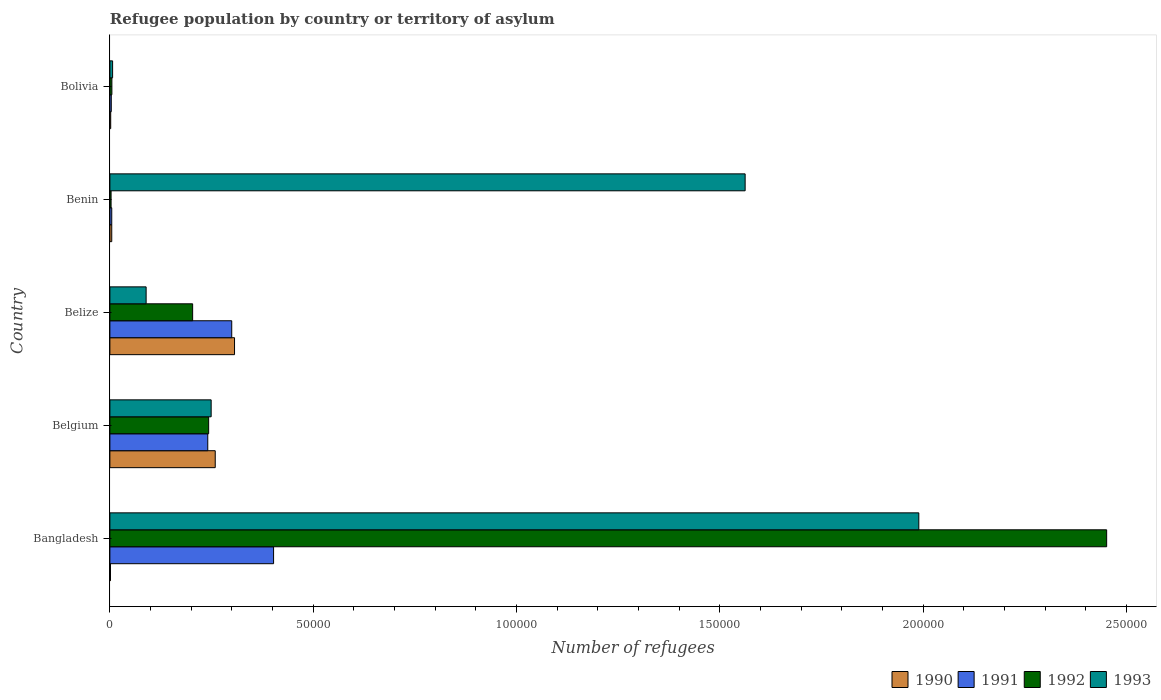How many different coloured bars are there?
Offer a very short reply. 4. How many groups of bars are there?
Your answer should be compact. 5. Are the number of bars per tick equal to the number of legend labels?
Your answer should be very brief. Yes. How many bars are there on the 3rd tick from the top?
Make the answer very short. 4. What is the label of the 5th group of bars from the top?
Your answer should be very brief. Bangladesh. What is the number of refugees in 1992 in Belize?
Offer a very short reply. 2.04e+04. Across all countries, what is the maximum number of refugees in 1991?
Provide a succinct answer. 4.03e+04. Across all countries, what is the minimum number of refugees in 1992?
Your response must be concise. 293. What is the total number of refugees in 1991 in the graph?
Your answer should be compact. 9.51e+04. What is the difference between the number of refugees in 1990 in Belgium and that in Bolivia?
Keep it short and to the point. 2.57e+04. What is the difference between the number of refugees in 1993 in Bolivia and the number of refugees in 1990 in Benin?
Offer a terse response. 213. What is the average number of refugees in 1991 per country?
Provide a short and direct response. 1.90e+04. What is the difference between the number of refugees in 1990 and number of refugees in 1991 in Bangladesh?
Your answer should be compact. -4.01e+04. In how many countries, is the number of refugees in 1991 greater than 90000 ?
Offer a very short reply. 0. What is the ratio of the number of refugees in 1993 in Belize to that in Bolivia?
Ensure brevity in your answer.  13.32. Is the difference between the number of refugees in 1990 in Belgium and Bolivia greater than the difference between the number of refugees in 1991 in Belgium and Bolivia?
Your answer should be compact. Yes. What is the difference between the highest and the second highest number of refugees in 1993?
Offer a very short reply. 4.27e+04. What is the difference between the highest and the lowest number of refugees in 1993?
Your answer should be compact. 1.98e+05. In how many countries, is the number of refugees in 1991 greater than the average number of refugees in 1991 taken over all countries?
Your answer should be compact. 3. What does the 3rd bar from the top in Bangladesh represents?
Your answer should be compact. 1991. What does the 4th bar from the bottom in Belgium represents?
Make the answer very short. 1993. Is it the case that in every country, the sum of the number of refugees in 1990 and number of refugees in 1992 is greater than the number of refugees in 1993?
Your answer should be compact. No. How many bars are there?
Offer a terse response. 20. Are all the bars in the graph horizontal?
Give a very brief answer. Yes. Does the graph contain grids?
Ensure brevity in your answer.  No. What is the title of the graph?
Give a very brief answer. Refugee population by country or territory of asylum. What is the label or title of the X-axis?
Keep it short and to the point. Number of refugees. What is the label or title of the Y-axis?
Provide a succinct answer. Country. What is the Number of refugees of 1990 in Bangladesh?
Give a very brief answer. 145. What is the Number of refugees in 1991 in Bangladesh?
Offer a terse response. 4.03e+04. What is the Number of refugees in 1992 in Bangladesh?
Your answer should be very brief. 2.45e+05. What is the Number of refugees in 1993 in Bangladesh?
Keep it short and to the point. 1.99e+05. What is the Number of refugees of 1990 in Belgium?
Your answer should be compact. 2.59e+04. What is the Number of refugees of 1991 in Belgium?
Ensure brevity in your answer.  2.41e+04. What is the Number of refugees of 1992 in Belgium?
Your answer should be compact. 2.43e+04. What is the Number of refugees in 1993 in Belgium?
Keep it short and to the point. 2.49e+04. What is the Number of refugees in 1990 in Belize?
Provide a short and direct response. 3.07e+04. What is the Number of refugees of 1991 in Belize?
Make the answer very short. 3.00e+04. What is the Number of refugees of 1992 in Belize?
Keep it short and to the point. 2.04e+04. What is the Number of refugees in 1993 in Belize?
Your response must be concise. 8912. What is the Number of refugees of 1990 in Benin?
Make the answer very short. 456. What is the Number of refugees in 1991 in Benin?
Keep it short and to the point. 456. What is the Number of refugees in 1992 in Benin?
Offer a very short reply. 293. What is the Number of refugees of 1993 in Benin?
Make the answer very short. 1.56e+05. What is the Number of refugees in 1990 in Bolivia?
Keep it short and to the point. 200. What is the Number of refugees of 1991 in Bolivia?
Your response must be concise. 341. What is the Number of refugees of 1992 in Bolivia?
Provide a short and direct response. 491. What is the Number of refugees of 1993 in Bolivia?
Ensure brevity in your answer.  669. Across all countries, what is the maximum Number of refugees of 1990?
Ensure brevity in your answer.  3.07e+04. Across all countries, what is the maximum Number of refugees of 1991?
Ensure brevity in your answer.  4.03e+04. Across all countries, what is the maximum Number of refugees in 1992?
Provide a short and direct response. 2.45e+05. Across all countries, what is the maximum Number of refugees in 1993?
Offer a very short reply. 1.99e+05. Across all countries, what is the minimum Number of refugees of 1990?
Give a very brief answer. 145. Across all countries, what is the minimum Number of refugees in 1991?
Ensure brevity in your answer.  341. Across all countries, what is the minimum Number of refugees of 1992?
Provide a short and direct response. 293. Across all countries, what is the minimum Number of refugees in 1993?
Your answer should be compact. 669. What is the total Number of refugees of 1990 in the graph?
Make the answer very short. 5.74e+04. What is the total Number of refugees in 1991 in the graph?
Offer a terse response. 9.51e+04. What is the total Number of refugees of 1992 in the graph?
Your answer should be compact. 2.91e+05. What is the total Number of refugees of 1993 in the graph?
Keep it short and to the point. 3.90e+05. What is the difference between the Number of refugees of 1990 in Bangladesh and that in Belgium?
Make the answer very short. -2.58e+04. What is the difference between the Number of refugees of 1991 in Bangladesh and that in Belgium?
Your answer should be very brief. 1.62e+04. What is the difference between the Number of refugees of 1992 in Bangladesh and that in Belgium?
Your answer should be compact. 2.21e+05. What is the difference between the Number of refugees in 1993 in Bangladesh and that in Belgium?
Offer a very short reply. 1.74e+05. What is the difference between the Number of refugees of 1990 in Bangladesh and that in Belize?
Keep it short and to the point. -3.05e+04. What is the difference between the Number of refugees in 1991 in Bangladesh and that in Belize?
Offer a very short reply. 1.03e+04. What is the difference between the Number of refugees of 1992 in Bangladesh and that in Belize?
Make the answer very short. 2.25e+05. What is the difference between the Number of refugees of 1993 in Bangladesh and that in Belize?
Give a very brief answer. 1.90e+05. What is the difference between the Number of refugees of 1990 in Bangladesh and that in Benin?
Offer a very short reply. -311. What is the difference between the Number of refugees in 1991 in Bangladesh and that in Benin?
Give a very brief answer. 3.98e+04. What is the difference between the Number of refugees in 1992 in Bangladesh and that in Benin?
Offer a terse response. 2.45e+05. What is the difference between the Number of refugees in 1993 in Bangladesh and that in Benin?
Your answer should be compact. 4.27e+04. What is the difference between the Number of refugees in 1990 in Bangladesh and that in Bolivia?
Make the answer very short. -55. What is the difference between the Number of refugees in 1991 in Bangladesh and that in Bolivia?
Your response must be concise. 3.99e+04. What is the difference between the Number of refugees of 1992 in Bangladesh and that in Bolivia?
Keep it short and to the point. 2.45e+05. What is the difference between the Number of refugees of 1993 in Bangladesh and that in Bolivia?
Your response must be concise. 1.98e+05. What is the difference between the Number of refugees of 1990 in Belgium and that in Belize?
Give a very brief answer. -4746. What is the difference between the Number of refugees in 1991 in Belgium and that in Belize?
Give a very brief answer. -5898. What is the difference between the Number of refugees in 1992 in Belgium and that in Belize?
Offer a terse response. 3941. What is the difference between the Number of refugees of 1993 in Belgium and that in Belize?
Your answer should be very brief. 1.60e+04. What is the difference between the Number of refugees of 1990 in Belgium and that in Benin?
Make the answer very short. 2.55e+04. What is the difference between the Number of refugees of 1991 in Belgium and that in Benin?
Offer a very short reply. 2.36e+04. What is the difference between the Number of refugees in 1992 in Belgium and that in Benin?
Your response must be concise. 2.40e+04. What is the difference between the Number of refugees of 1993 in Belgium and that in Benin?
Make the answer very short. -1.31e+05. What is the difference between the Number of refugees in 1990 in Belgium and that in Bolivia?
Your answer should be compact. 2.57e+04. What is the difference between the Number of refugees of 1991 in Belgium and that in Bolivia?
Give a very brief answer. 2.37e+04. What is the difference between the Number of refugees in 1992 in Belgium and that in Bolivia?
Provide a succinct answer. 2.38e+04. What is the difference between the Number of refugees in 1993 in Belgium and that in Bolivia?
Offer a very short reply. 2.42e+04. What is the difference between the Number of refugees of 1990 in Belize and that in Benin?
Your response must be concise. 3.02e+04. What is the difference between the Number of refugees in 1991 in Belize and that in Benin?
Offer a very short reply. 2.95e+04. What is the difference between the Number of refugees of 1992 in Belize and that in Benin?
Give a very brief answer. 2.01e+04. What is the difference between the Number of refugees of 1993 in Belize and that in Benin?
Offer a very short reply. -1.47e+05. What is the difference between the Number of refugees of 1990 in Belize and that in Bolivia?
Your response must be concise. 3.05e+04. What is the difference between the Number of refugees in 1991 in Belize and that in Bolivia?
Make the answer very short. 2.96e+04. What is the difference between the Number of refugees in 1992 in Belize and that in Bolivia?
Offer a very short reply. 1.99e+04. What is the difference between the Number of refugees of 1993 in Belize and that in Bolivia?
Ensure brevity in your answer.  8243. What is the difference between the Number of refugees in 1990 in Benin and that in Bolivia?
Keep it short and to the point. 256. What is the difference between the Number of refugees in 1991 in Benin and that in Bolivia?
Your answer should be very brief. 115. What is the difference between the Number of refugees of 1992 in Benin and that in Bolivia?
Give a very brief answer. -198. What is the difference between the Number of refugees in 1993 in Benin and that in Bolivia?
Your answer should be very brief. 1.56e+05. What is the difference between the Number of refugees of 1990 in Bangladesh and the Number of refugees of 1991 in Belgium?
Your answer should be compact. -2.39e+04. What is the difference between the Number of refugees in 1990 in Bangladesh and the Number of refugees in 1992 in Belgium?
Make the answer very short. -2.41e+04. What is the difference between the Number of refugees of 1990 in Bangladesh and the Number of refugees of 1993 in Belgium?
Offer a very short reply. -2.48e+04. What is the difference between the Number of refugees in 1991 in Bangladesh and the Number of refugees in 1992 in Belgium?
Keep it short and to the point. 1.60e+04. What is the difference between the Number of refugees in 1991 in Bangladesh and the Number of refugees in 1993 in Belgium?
Your answer should be very brief. 1.54e+04. What is the difference between the Number of refugees in 1992 in Bangladesh and the Number of refugees in 1993 in Belgium?
Provide a short and direct response. 2.20e+05. What is the difference between the Number of refugees in 1990 in Bangladesh and the Number of refugees in 1991 in Belize?
Your answer should be very brief. -2.98e+04. What is the difference between the Number of refugees of 1990 in Bangladesh and the Number of refugees of 1992 in Belize?
Offer a very short reply. -2.02e+04. What is the difference between the Number of refugees in 1990 in Bangladesh and the Number of refugees in 1993 in Belize?
Offer a terse response. -8767. What is the difference between the Number of refugees of 1991 in Bangladesh and the Number of refugees of 1992 in Belize?
Your answer should be compact. 1.99e+04. What is the difference between the Number of refugees of 1991 in Bangladesh and the Number of refugees of 1993 in Belize?
Ensure brevity in your answer.  3.13e+04. What is the difference between the Number of refugees of 1992 in Bangladesh and the Number of refugees of 1993 in Belize?
Your answer should be very brief. 2.36e+05. What is the difference between the Number of refugees in 1990 in Bangladesh and the Number of refugees in 1991 in Benin?
Give a very brief answer. -311. What is the difference between the Number of refugees in 1990 in Bangladesh and the Number of refugees in 1992 in Benin?
Your response must be concise. -148. What is the difference between the Number of refugees in 1990 in Bangladesh and the Number of refugees in 1993 in Benin?
Offer a very short reply. -1.56e+05. What is the difference between the Number of refugees in 1991 in Bangladesh and the Number of refugees in 1992 in Benin?
Offer a terse response. 4.00e+04. What is the difference between the Number of refugees of 1991 in Bangladesh and the Number of refugees of 1993 in Benin?
Provide a succinct answer. -1.16e+05. What is the difference between the Number of refugees in 1992 in Bangladesh and the Number of refugees in 1993 in Benin?
Provide a succinct answer. 8.89e+04. What is the difference between the Number of refugees in 1990 in Bangladesh and the Number of refugees in 1991 in Bolivia?
Make the answer very short. -196. What is the difference between the Number of refugees of 1990 in Bangladesh and the Number of refugees of 1992 in Bolivia?
Ensure brevity in your answer.  -346. What is the difference between the Number of refugees in 1990 in Bangladesh and the Number of refugees in 1993 in Bolivia?
Ensure brevity in your answer.  -524. What is the difference between the Number of refugees of 1991 in Bangladesh and the Number of refugees of 1992 in Bolivia?
Keep it short and to the point. 3.98e+04. What is the difference between the Number of refugees of 1991 in Bangladesh and the Number of refugees of 1993 in Bolivia?
Your response must be concise. 3.96e+04. What is the difference between the Number of refugees of 1992 in Bangladesh and the Number of refugees of 1993 in Bolivia?
Make the answer very short. 2.44e+05. What is the difference between the Number of refugees of 1990 in Belgium and the Number of refugees of 1991 in Belize?
Keep it short and to the point. -4058. What is the difference between the Number of refugees in 1990 in Belgium and the Number of refugees in 1992 in Belize?
Offer a very short reply. 5560. What is the difference between the Number of refugees of 1990 in Belgium and the Number of refugees of 1993 in Belize?
Keep it short and to the point. 1.70e+04. What is the difference between the Number of refugees in 1991 in Belgium and the Number of refugees in 1992 in Belize?
Ensure brevity in your answer.  3720. What is the difference between the Number of refugees in 1991 in Belgium and the Number of refugees in 1993 in Belize?
Your answer should be compact. 1.52e+04. What is the difference between the Number of refugees in 1992 in Belgium and the Number of refugees in 1993 in Belize?
Offer a terse response. 1.54e+04. What is the difference between the Number of refugees in 1990 in Belgium and the Number of refugees in 1991 in Benin?
Give a very brief answer. 2.55e+04. What is the difference between the Number of refugees in 1990 in Belgium and the Number of refugees in 1992 in Benin?
Offer a terse response. 2.56e+04. What is the difference between the Number of refugees of 1990 in Belgium and the Number of refugees of 1993 in Benin?
Offer a very short reply. -1.30e+05. What is the difference between the Number of refugees of 1991 in Belgium and the Number of refugees of 1992 in Benin?
Your response must be concise. 2.38e+04. What is the difference between the Number of refugees of 1991 in Belgium and the Number of refugees of 1993 in Benin?
Provide a short and direct response. -1.32e+05. What is the difference between the Number of refugees in 1992 in Belgium and the Number of refugees in 1993 in Benin?
Give a very brief answer. -1.32e+05. What is the difference between the Number of refugees of 1990 in Belgium and the Number of refugees of 1991 in Bolivia?
Keep it short and to the point. 2.56e+04. What is the difference between the Number of refugees in 1990 in Belgium and the Number of refugees in 1992 in Bolivia?
Offer a very short reply. 2.54e+04. What is the difference between the Number of refugees of 1990 in Belgium and the Number of refugees of 1993 in Bolivia?
Give a very brief answer. 2.52e+04. What is the difference between the Number of refugees in 1991 in Belgium and the Number of refugees in 1992 in Bolivia?
Your response must be concise. 2.36e+04. What is the difference between the Number of refugees in 1991 in Belgium and the Number of refugees in 1993 in Bolivia?
Your answer should be very brief. 2.34e+04. What is the difference between the Number of refugees in 1992 in Belgium and the Number of refugees in 1993 in Bolivia?
Make the answer very short. 2.36e+04. What is the difference between the Number of refugees in 1990 in Belize and the Number of refugees in 1991 in Benin?
Ensure brevity in your answer.  3.02e+04. What is the difference between the Number of refugees in 1990 in Belize and the Number of refugees in 1992 in Benin?
Offer a very short reply. 3.04e+04. What is the difference between the Number of refugees in 1990 in Belize and the Number of refugees in 1993 in Benin?
Give a very brief answer. -1.26e+05. What is the difference between the Number of refugees in 1991 in Belize and the Number of refugees in 1992 in Benin?
Ensure brevity in your answer.  2.97e+04. What is the difference between the Number of refugees of 1991 in Belize and the Number of refugees of 1993 in Benin?
Ensure brevity in your answer.  -1.26e+05. What is the difference between the Number of refugees in 1992 in Belize and the Number of refugees in 1993 in Benin?
Your answer should be very brief. -1.36e+05. What is the difference between the Number of refugees of 1990 in Belize and the Number of refugees of 1991 in Bolivia?
Give a very brief answer. 3.03e+04. What is the difference between the Number of refugees of 1990 in Belize and the Number of refugees of 1992 in Bolivia?
Keep it short and to the point. 3.02e+04. What is the difference between the Number of refugees in 1990 in Belize and the Number of refugees in 1993 in Bolivia?
Offer a terse response. 3.00e+04. What is the difference between the Number of refugees of 1991 in Belize and the Number of refugees of 1992 in Bolivia?
Your answer should be compact. 2.95e+04. What is the difference between the Number of refugees of 1991 in Belize and the Number of refugees of 1993 in Bolivia?
Offer a terse response. 2.93e+04. What is the difference between the Number of refugees in 1992 in Belize and the Number of refugees in 1993 in Bolivia?
Ensure brevity in your answer.  1.97e+04. What is the difference between the Number of refugees in 1990 in Benin and the Number of refugees in 1991 in Bolivia?
Make the answer very short. 115. What is the difference between the Number of refugees in 1990 in Benin and the Number of refugees in 1992 in Bolivia?
Give a very brief answer. -35. What is the difference between the Number of refugees in 1990 in Benin and the Number of refugees in 1993 in Bolivia?
Ensure brevity in your answer.  -213. What is the difference between the Number of refugees in 1991 in Benin and the Number of refugees in 1992 in Bolivia?
Keep it short and to the point. -35. What is the difference between the Number of refugees of 1991 in Benin and the Number of refugees of 1993 in Bolivia?
Ensure brevity in your answer.  -213. What is the difference between the Number of refugees in 1992 in Benin and the Number of refugees in 1993 in Bolivia?
Offer a terse response. -376. What is the average Number of refugees in 1990 per country?
Your answer should be very brief. 1.15e+04. What is the average Number of refugees of 1991 per country?
Your response must be concise. 1.90e+04. What is the average Number of refugees of 1992 per country?
Give a very brief answer. 5.81e+04. What is the average Number of refugees of 1993 per country?
Offer a terse response. 7.79e+04. What is the difference between the Number of refugees of 1990 and Number of refugees of 1991 in Bangladesh?
Offer a terse response. -4.01e+04. What is the difference between the Number of refugees in 1990 and Number of refugees in 1992 in Bangladesh?
Offer a terse response. -2.45e+05. What is the difference between the Number of refugees in 1990 and Number of refugees in 1993 in Bangladesh?
Make the answer very short. -1.99e+05. What is the difference between the Number of refugees in 1991 and Number of refugees in 1992 in Bangladesh?
Ensure brevity in your answer.  -2.05e+05. What is the difference between the Number of refugees of 1991 and Number of refugees of 1993 in Bangladesh?
Your response must be concise. -1.59e+05. What is the difference between the Number of refugees of 1992 and Number of refugees of 1993 in Bangladesh?
Give a very brief answer. 4.62e+04. What is the difference between the Number of refugees of 1990 and Number of refugees of 1991 in Belgium?
Keep it short and to the point. 1840. What is the difference between the Number of refugees of 1990 and Number of refugees of 1992 in Belgium?
Provide a succinct answer. 1619. What is the difference between the Number of refugees of 1990 and Number of refugees of 1993 in Belgium?
Provide a short and direct response. 1003. What is the difference between the Number of refugees of 1991 and Number of refugees of 1992 in Belgium?
Provide a short and direct response. -221. What is the difference between the Number of refugees of 1991 and Number of refugees of 1993 in Belgium?
Give a very brief answer. -837. What is the difference between the Number of refugees of 1992 and Number of refugees of 1993 in Belgium?
Your answer should be compact. -616. What is the difference between the Number of refugees in 1990 and Number of refugees in 1991 in Belize?
Provide a short and direct response. 688. What is the difference between the Number of refugees of 1990 and Number of refugees of 1992 in Belize?
Keep it short and to the point. 1.03e+04. What is the difference between the Number of refugees in 1990 and Number of refugees in 1993 in Belize?
Your answer should be compact. 2.17e+04. What is the difference between the Number of refugees in 1991 and Number of refugees in 1992 in Belize?
Provide a short and direct response. 9618. What is the difference between the Number of refugees in 1991 and Number of refugees in 1993 in Belize?
Provide a succinct answer. 2.11e+04. What is the difference between the Number of refugees in 1992 and Number of refugees in 1993 in Belize?
Ensure brevity in your answer.  1.14e+04. What is the difference between the Number of refugees in 1990 and Number of refugees in 1992 in Benin?
Your response must be concise. 163. What is the difference between the Number of refugees of 1990 and Number of refugees of 1993 in Benin?
Make the answer very short. -1.56e+05. What is the difference between the Number of refugees in 1991 and Number of refugees in 1992 in Benin?
Offer a terse response. 163. What is the difference between the Number of refugees in 1991 and Number of refugees in 1993 in Benin?
Your response must be concise. -1.56e+05. What is the difference between the Number of refugees of 1992 and Number of refugees of 1993 in Benin?
Your response must be concise. -1.56e+05. What is the difference between the Number of refugees of 1990 and Number of refugees of 1991 in Bolivia?
Your answer should be compact. -141. What is the difference between the Number of refugees of 1990 and Number of refugees of 1992 in Bolivia?
Keep it short and to the point. -291. What is the difference between the Number of refugees of 1990 and Number of refugees of 1993 in Bolivia?
Your response must be concise. -469. What is the difference between the Number of refugees of 1991 and Number of refugees of 1992 in Bolivia?
Offer a terse response. -150. What is the difference between the Number of refugees of 1991 and Number of refugees of 1993 in Bolivia?
Your answer should be compact. -328. What is the difference between the Number of refugees in 1992 and Number of refugees in 1993 in Bolivia?
Ensure brevity in your answer.  -178. What is the ratio of the Number of refugees in 1990 in Bangladesh to that in Belgium?
Ensure brevity in your answer.  0.01. What is the ratio of the Number of refugees of 1991 in Bangladesh to that in Belgium?
Make the answer very short. 1.67. What is the ratio of the Number of refugees of 1992 in Bangladesh to that in Belgium?
Provide a succinct answer. 10.09. What is the ratio of the Number of refugees in 1993 in Bangladesh to that in Belgium?
Offer a very short reply. 7.99. What is the ratio of the Number of refugees of 1990 in Bangladesh to that in Belize?
Give a very brief answer. 0. What is the ratio of the Number of refugees in 1991 in Bangladesh to that in Belize?
Offer a terse response. 1.34. What is the ratio of the Number of refugees in 1992 in Bangladesh to that in Belize?
Ensure brevity in your answer.  12.05. What is the ratio of the Number of refugees in 1993 in Bangladesh to that in Belize?
Make the answer very short. 22.32. What is the ratio of the Number of refugees in 1990 in Bangladesh to that in Benin?
Ensure brevity in your answer.  0.32. What is the ratio of the Number of refugees in 1991 in Bangladesh to that in Benin?
Your response must be concise. 88.29. What is the ratio of the Number of refugees in 1992 in Bangladesh to that in Benin?
Offer a terse response. 836.7. What is the ratio of the Number of refugees of 1993 in Bangladesh to that in Benin?
Offer a very short reply. 1.27. What is the ratio of the Number of refugees in 1990 in Bangladesh to that in Bolivia?
Offer a terse response. 0.72. What is the ratio of the Number of refugees in 1991 in Bangladesh to that in Bolivia?
Ensure brevity in your answer.  118.06. What is the ratio of the Number of refugees in 1992 in Bangladesh to that in Bolivia?
Offer a terse response. 499.3. What is the ratio of the Number of refugees in 1993 in Bangladesh to that in Bolivia?
Make the answer very short. 297.39. What is the ratio of the Number of refugees in 1990 in Belgium to that in Belize?
Make the answer very short. 0.85. What is the ratio of the Number of refugees of 1991 in Belgium to that in Belize?
Offer a very short reply. 0.8. What is the ratio of the Number of refugees in 1992 in Belgium to that in Belize?
Make the answer very short. 1.19. What is the ratio of the Number of refugees of 1993 in Belgium to that in Belize?
Provide a short and direct response. 2.79. What is the ratio of the Number of refugees of 1990 in Belgium to that in Benin?
Offer a very short reply. 56.82. What is the ratio of the Number of refugees of 1991 in Belgium to that in Benin?
Provide a short and direct response. 52.79. What is the ratio of the Number of refugees in 1992 in Belgium to that in Benin?
Your answer should be very brief. 82.91. What is the ratio of the Number of refugees in 1993 in Belgium to that in Benin?
Make the answer very short. 0.16. What is the ratio of the Number of refugees in 1990 in Belgium to that in Bolivia?
Your answer should be compact. 129.56. What is the ratio of the Number of refugees in 1991 in Belgium to that in Bolivia?
Your answer should be very brief. 70.59. What is the ratio of the Number of refugees of 1992 in Belgium to that in Bolivia?
Make the answer very short. 49.47. What is the ratio of the Number of refugees in 1993 in Belgium to that in Bolivia?
Your response must be concise. 37.23. What is the ratio of the Number of refugees of 1990 in Belize to that in Benin?
Your answer should be very brief. 67.23. What is the ratio of the Number of refugees in 1991 in Belize to that in Benin?
Your answer should be very brief. 65.72. What is the ratio of the Number of refugees in 1992 in Belize to that in Benin?
Give a very brief answer. 69.46. What is the ratio of the Number of refugees in 1993 in Belize to that in Benin?
Your answer should be compact. 0.06. What is the ratio of the Number of refugees in 1990 in Belize to that in Bolivia?
Offer a terse response. 153.28. What is the ratio of the Number of refugees in 1991 in Belize to that in Bolivia?
Your answer should be very brief. 87.89. What is the ratio of the Number of refugees in 1992 in Belize to that in Bolivia?
Keep it short and to the point. 41.45. What is the ratio of the Number of refugees in 1993 in Belize to that in Bolivia?
Provide a succinct answer. 13.32. What is the ratio of the Number of refugees of 1990 in Benin to that in Bolivia?
Keep it short and to the point. 2.28. What is the ratio of the Number of refugees in 1991 in Benin to that in Bolivia?
Provide a short and direct response. 1.34. What is the ratio of the Number of refugees of 1992 in Benin to that in Bolivia?
Keep it short and to the point. 0.6. What is the ratio of the Number of refugees in 1993 in Benin to that in Bolivia?
Make the answer very short. 233.54. What is the difference between the highest and the second highest Number of refugees of 1990?
Provide a short and direct response. 4746. What is the difference between the highest and the second highest Number of refugees of 1991?
Ensure brevity in your answer.  1.03e+04. What is the difference between the highest and the second highest Number of refugees of 1992?
Provide a short and direct response. 2.21e+05. What is the difference between the highest and the second highest Number of refugees of 1993?
Your answer should be very brief. 4.27e+04. What is the difference between the highest and the lowest Number of refugees in 1990?
Give a very brief answer. 3.05e+04. What is the difference between the highest and the lowest Number of refugees in 1991?
Your answer should be compact. 3.99e+04. What is the difference between the highest and the lowest Number of refugees in 1992?
Provide a short and direct response. 2.45e+05. What is the difference between the highest and the lowest Number of refugees in 1993?
Give a very brief answer. 1.98e+05. 